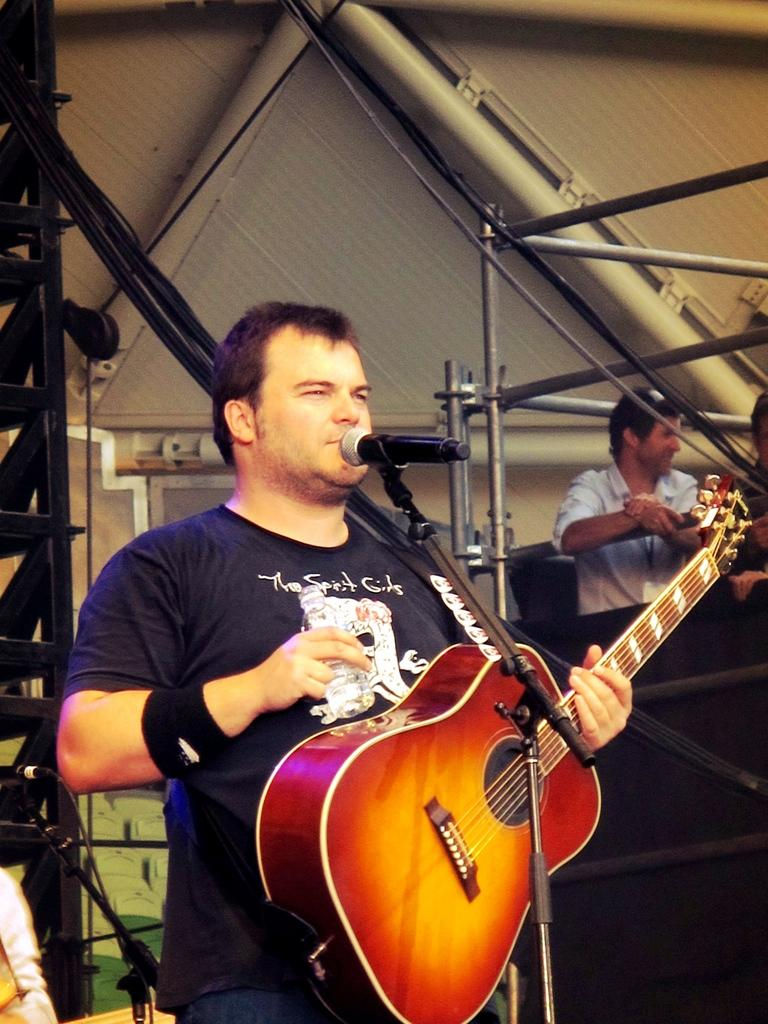What is the man in the image doing? The man is playing a guitar in the image. What object is the man standing in front of? The man is standing in front of a microphone. What accessory is the man wearing on his wrist? The man is wearing a wristband. Can you describe the presence of another person in the image? There is another person visible in the background of the image. What type of appliance is the man using to fix the wrench in the image? There is no wrench or appliance present in the image; the man is playing a guitar and standing in front of a microphone. 